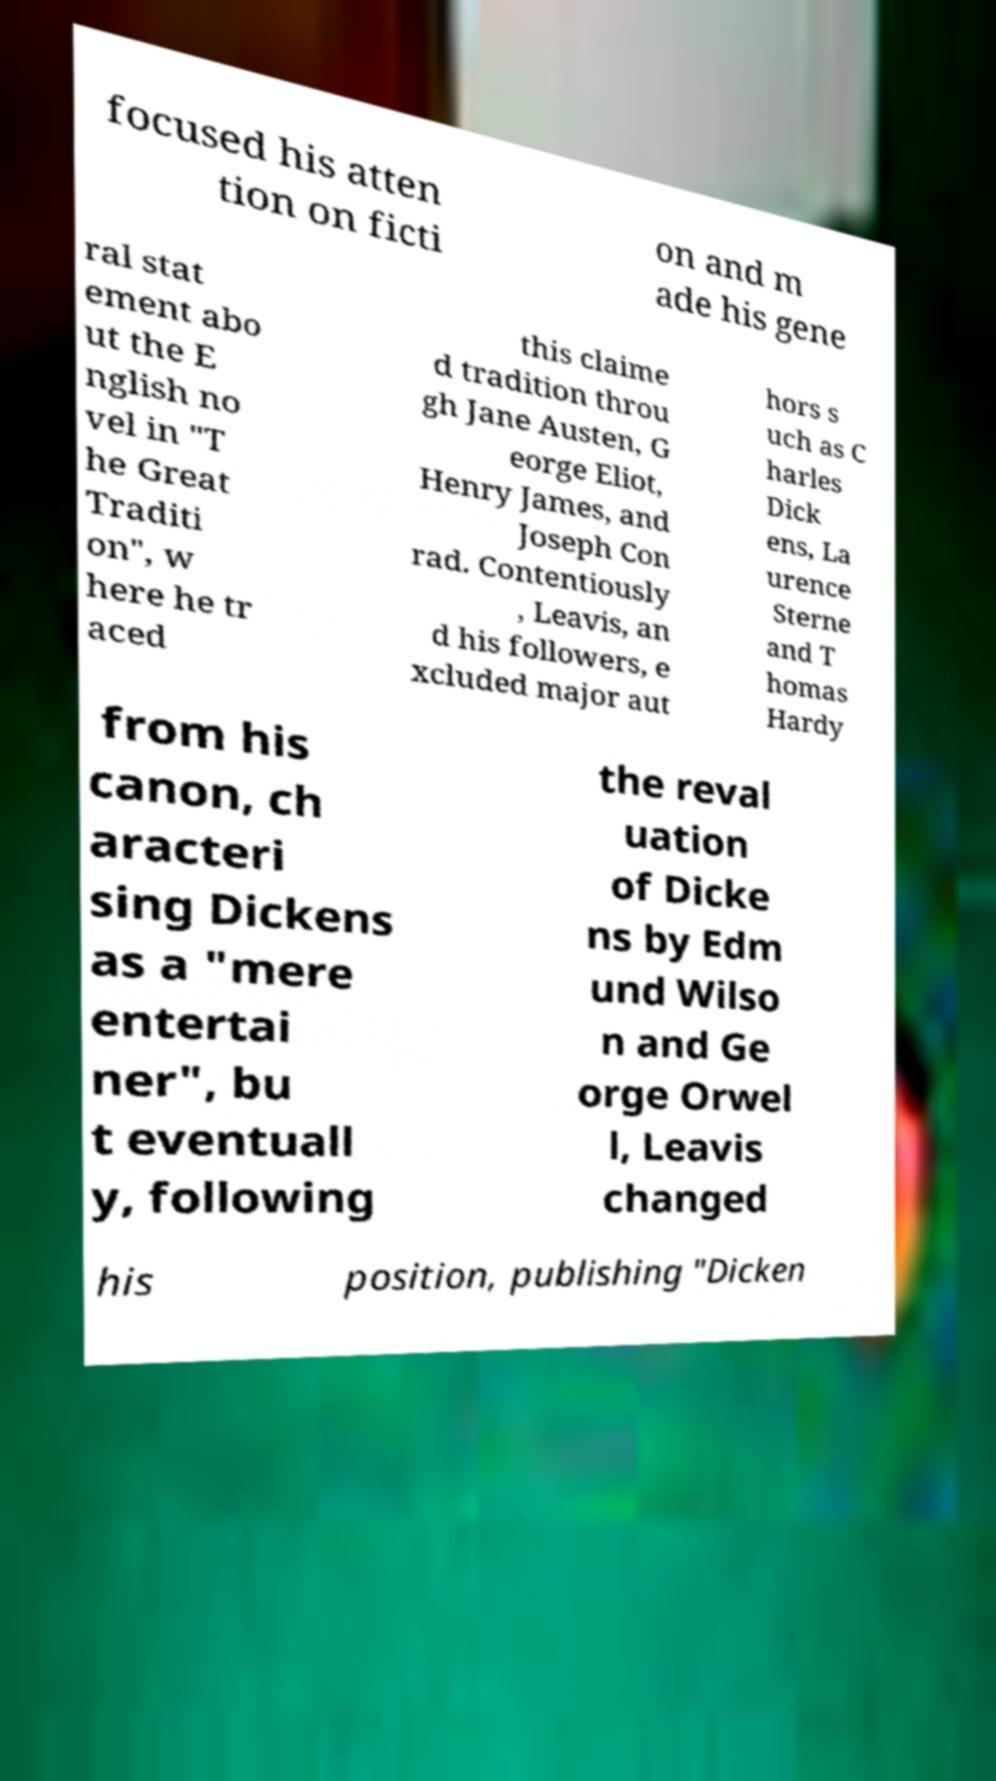Can you accurately transcribe the text from the provided image for me? focused his atten tion on ficti on and m ade his gene ral stat ement abo ut the E nglish no vel in "T he Great Traditi on", w here he tr aced this claime d tradition throu gh Jane Austen, G eorge Eliot, Henry James, and Joseph Con rad. Contentiously , Leavis, an d his followers, e xcluded major aut hors s uch as C harles Dick ens, La urence Sterne and T homas Hardy from his canon, ch aracteri sing Dickens as a "mere entertai ner", bu t eventuall y, following the reval uation of Dicke ns by Edm und Wilso n and Ge orge Orwel l, Leavis changed his position, publishing "Dicken 